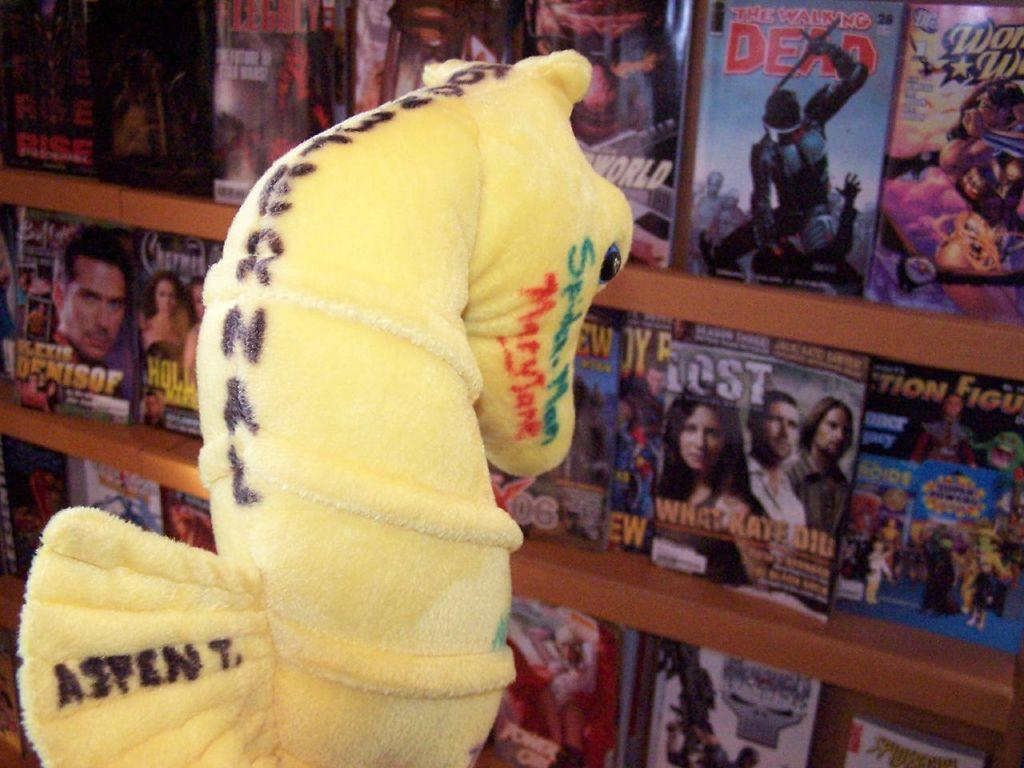What type of toy is present in the image? There is a toy horse in the image. What can be seen in the background of the image? In the background, there are books arranged in a rack. What is the price of the toy horse in the image? The price of the toy horse is not mentioned in the image, so it cannot be determined. 